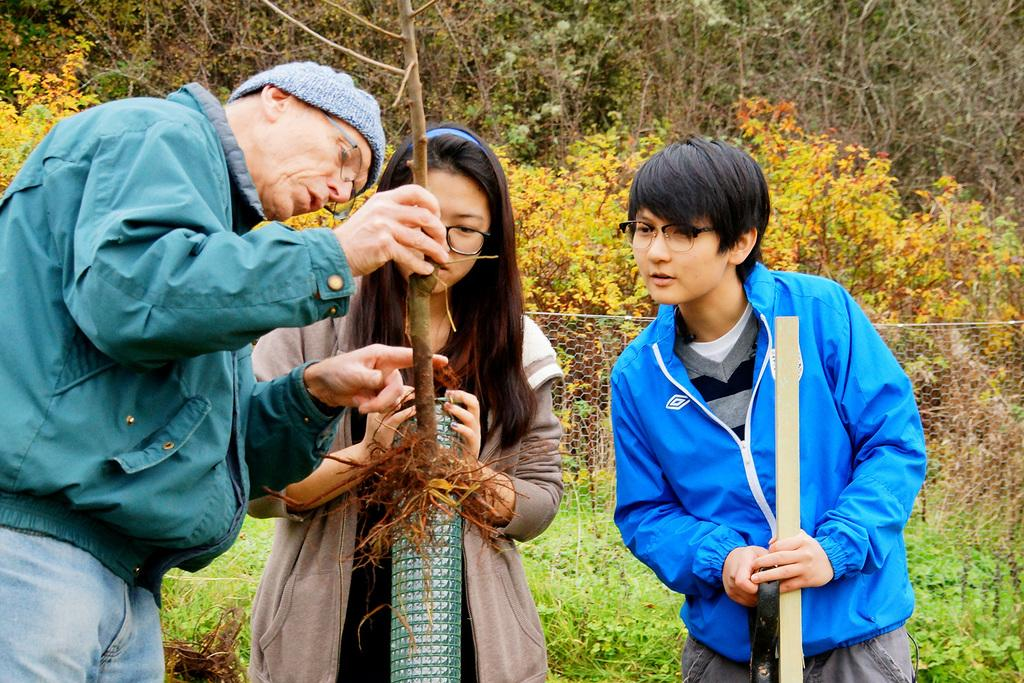How many people are present in the image? There are three people standing in the image. What is the man holding in the image? The man is holding a small tree with roots. What type of vegetation can be seen in the image? There are trees with branches and leaves in the image. What architectural feature is visible in the image? There appears to be a fence in the image. What type of picture is being pasted onto the tree in the image? There is no picture being pasted onto the tree in the image; the man is simply holding a small tree with roots. How does the man express his hate towards the trees in the image? There is no indication of hate or any negative emotion towards the trees in the image; the man is holding a small tree with roots, which suggests he might be planting or transporting it. 